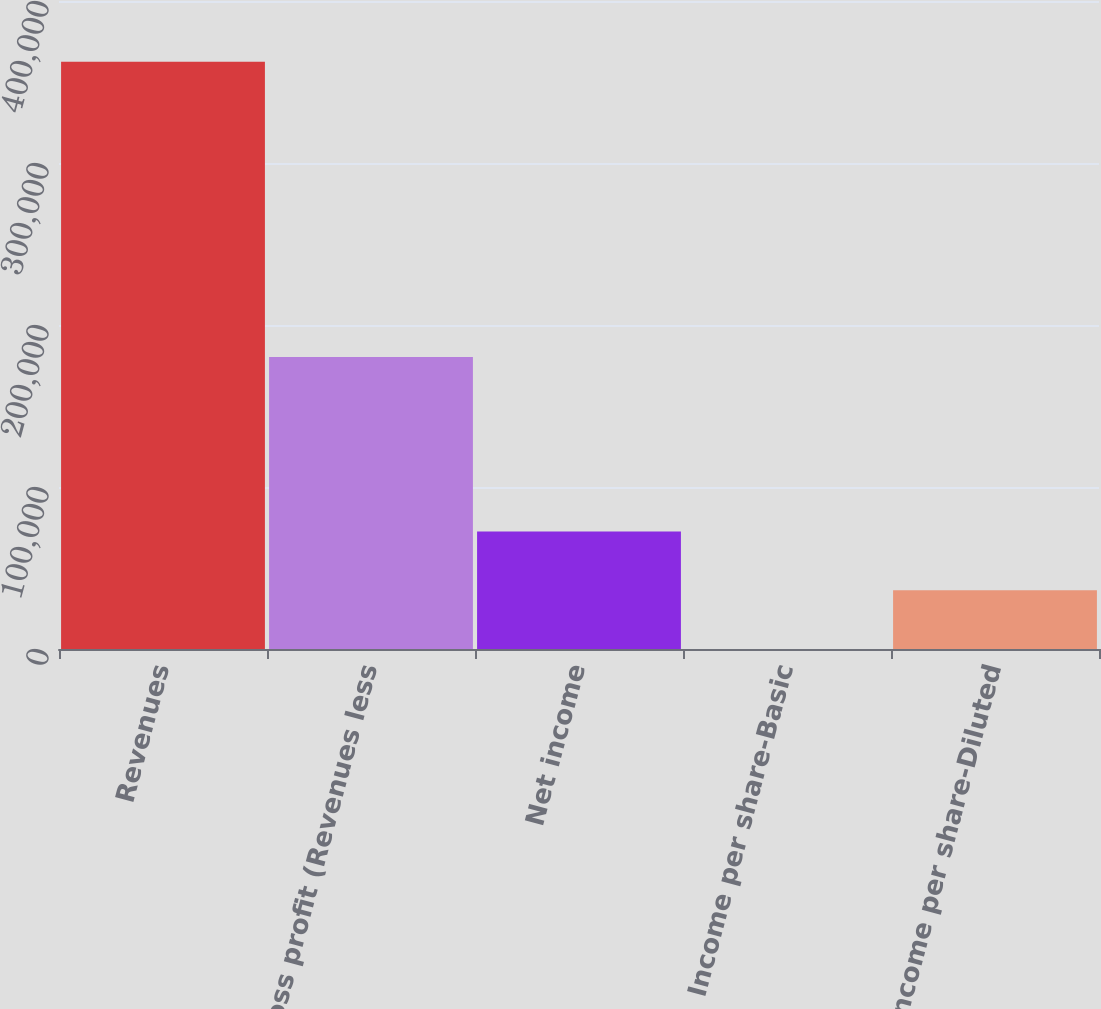Convert chart. <chart><loc_0><loc_0><loc_500><loc_500><bar_chart><fcel>Revenues<fcel>Gross profit (Revenues less<fcel>Net income<fcel>Income per share-Basic<fcel>Income per share-Diluted<nl><fcel>362500<fcel>180265<fcel>72500.1<fcel>0.15<fcel>36250.1<nl></chart> 